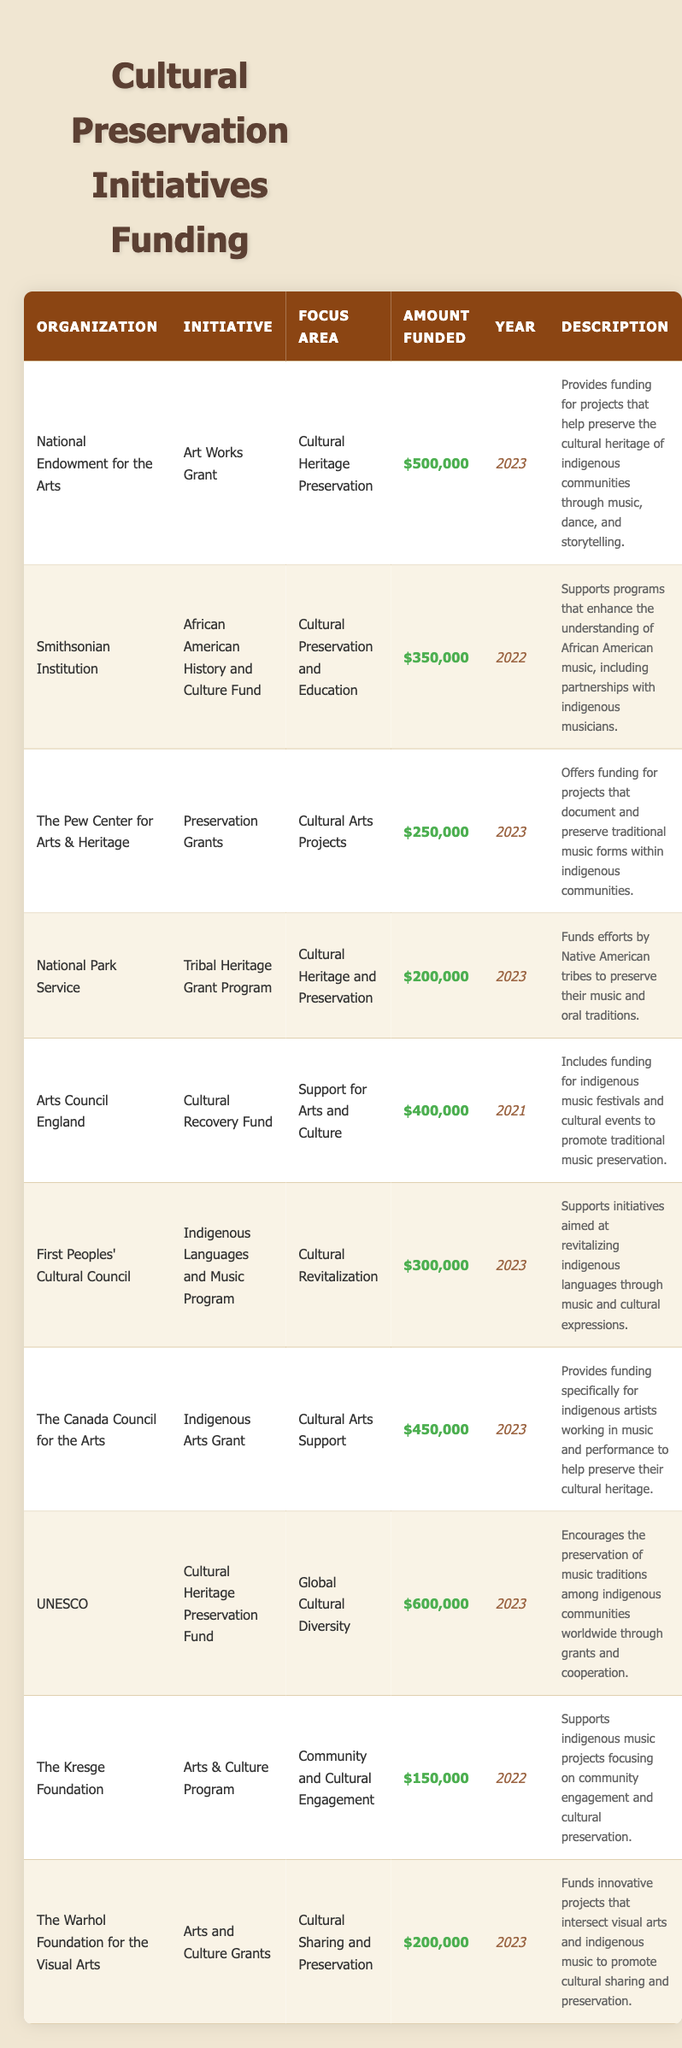What organization funded the highest amount for cultural preservation initiatives in 2023? The highest amount funded in 2023 is $600,000, provided by UNESCO for the Cultural Heritage Preservation Fund.
Answer: UNESCO What is the total amount funded by organizations for initiatives in 2023? The total for 2023 can be calculated by summing the amounts: $500,000 (NEA) + $250,000 (Pew Center) + $200,000 (National Park Service) + $300,000 (First Peoples) + $450,000 (Canada Council) + $600,000 (UNESCO) + $200,000 (Warhol Foundation) = $2,100,000.
Answer: $2,100,000 Did the Arts Council England provide funding for an initiative in 2023? No, the Arts Council England funded an initiative in 2021, not in 2023, as indicated in the year column.
Answer: No What is the difference in the amount funded between the initiative from the Smithsonian Institution and the one from National Park Service? The Smithsonian Institution funded $350,000 and the National Park Service funded $200,000. The difference is $350,000 - $200,000 = $150,000.
Answer: $150,000 Which organization has the initiative focusing on both education and cultural preservation? The Smithsonian Institution has the "African American History and Culture Fund" initiative, which focuses on cultural preservation and education.
Answer: Smithsonian Institution Calculate the average amount funded in 2022. In 2022, there are two organizations that funded initiatives: Smithsonian Institution ($350,000) and The Kresge Foundation ($150,000). The average is calculated as ($350,000 + $150,000) / 2 = $500,000 / 2 = $250,000.
Answer: $250,000 How many organizations provided funding specifically for projects related to indigenous music in 2023? The organizations that funded projects related to indigenous music in 2023 are: National Endowment for the Arts, The Pew Center for Arts & Heritage, First Peoples' Cultural Council, The Canada Council for the Arts, National Park Service, and The Warhol Foundation, totaling six organizations.
Answer: 6 Is there an organization that funded more than $400,000 in 2021? No, the only funding in 2021 was from Arts Council England for $400,000, which does not exceed that amount.
Answer: No Which two initiatives had the same funding amount in 2023? In 2023, the National Park Service ("Tribal Heritage Grant Program") and The Warhol Foundation ("Arts and Culture Grants") both had funding amounts of $200,000.
Answer: National Park Service and The Warhol Foundation What is the focus area of the initiative that received $450,000 in 2023? The $450,000 funding in 2023 is for the "Indigenous Arts Grant" by The Canada Council for the Arts, with a focus area on Cultural Arts Support.
Answer: Cultural Arts Support 